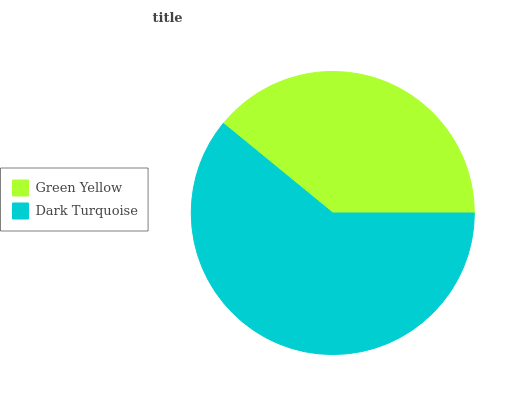Is Green Yellow the minimum?
Answer yes or no. Yes. Is Dark Turquoise the maximum?
Answer yes or no. Yes. Is Dark Turquoise the minimum?
Answer yes or no. No. Is Dark Turquoise greater than Green Yellow?
Answer yes or no. Yes. Is Green Yellow less than Dark Turquoise?
Answer yes or no. Yes. Is Green Yellow greater than Dark Turquoise?
Answer yes or no. No. Is Dark Turquoise less than Green Yellow?
Answer yes or no. No. Is Dark Turquoise the high median?
Answer yes or no. Yes. Is Green Yellow the low median?
Answer yes or no. Yes. Is Green Yellow the high median?
Answer yes or no. No. Is Dark Turquoise the low median?
Answer yes or no. No. 